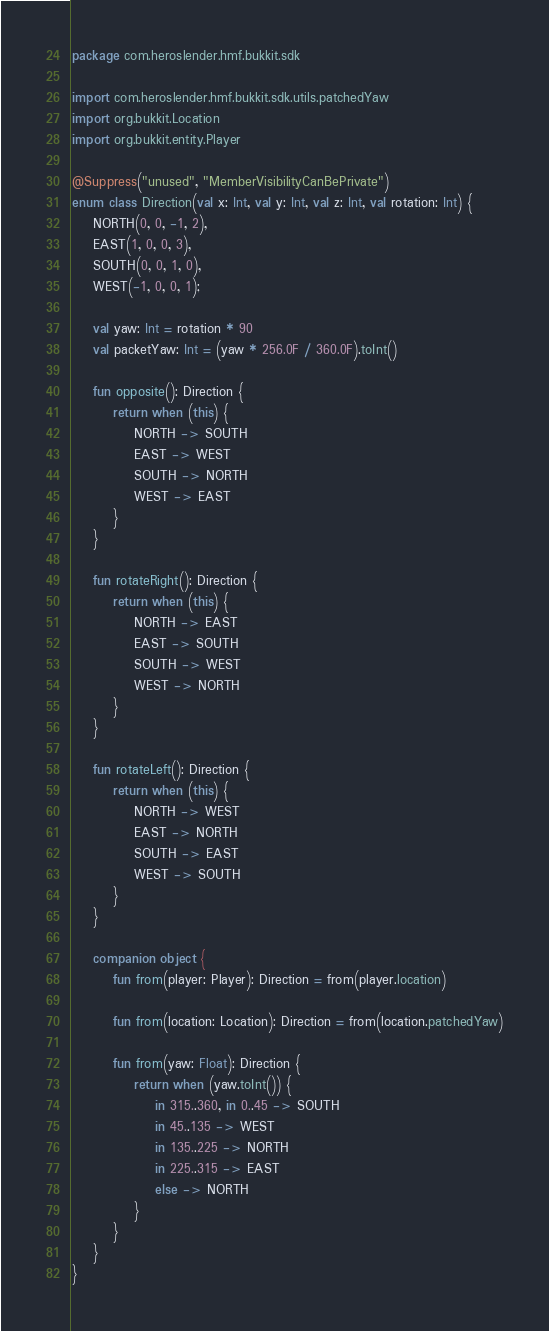Convert code to text. <code><loc_0><loc_0><loc_500><loc_500><_Kotlin_>package com.heroslender.hmf.bukkit.sdk

import com.heroslender.hmf.bukkit.sdk.utils.patchedYaw
import org.bukkit.Location
import org.bukkit.entity.Player

@Suppress("unused", "MemberVisibilityCanBePrivate")
enum class Direction(val x: Int, val y: Int, val z: Int, val rotation: Int) {
    NORTH(0, 0, -1, 2),
    EAST(1, 0, 0, 3),
    SOUTH(0, 0, 1, 0),
    WEST(-1, 0, 0, 1);

    val yaw: Int = rotation * 90
    val packetYaw: Int = (yaw * 256.0F / 360.0F).toInt()

    fun opposite(): Direction {
        return when (this) {
            NORTH -> SOUTH
            EAST -> WEST
            SOUTH -> NORTH
            WEST -> EAST
        }
    }

    fun rotateRight(): Direction {
        return when (this) {
            NORTH -> EAST
            EAST -> SOUTH
            SOUTH -> WEST
            WEST -> NORTH
        }
    }

    fun rotateLeft(): Direction {
        return when (this) {
            NORTH -> WEST
            EAST -> NORTH
            SOUTH -> EAST
            WEST -> SOUTH
        }
    }

    companion object {
        fun from(player: Player): Direction = from(player.location)

        fun from(location: Location): Direction = from(location.patchedYaw)

        fun from(yaw: Float): Direction {
            return when (yaw.toInt()) {
                in 315..360, in 0..45 -> SOUTH
                in 45..135 -> WEST
                in 135..225 -> NORTH
                in 225..315 -> EAST
                else -> NORTH
            }
        }
    }
}</code> 